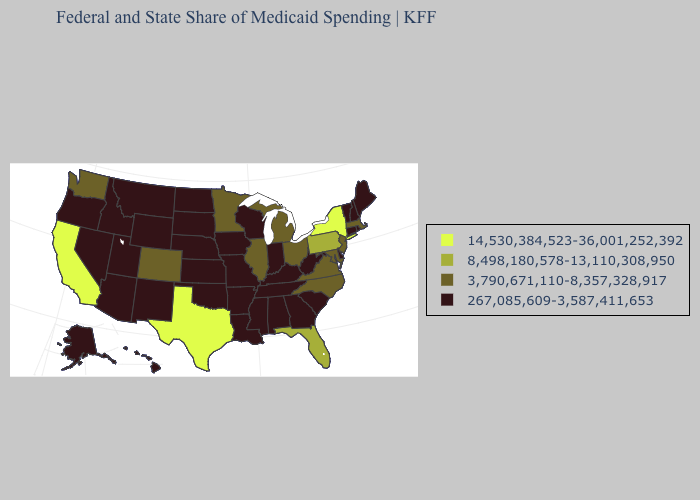Name the states that have a value in the range 267,085,609-3,587,411,653?
Concise answer only. Alabama, Alaska, Arizona, Arkansas, Connecticut, Delaware, Georgia, Hawaii, Idaho, Indiana, Iowa, Kansas, Kentucky, Louisiana, Maine, Mississippi, Missouri, Montana, Nebraska, Nevada, New Hampshire, New Mexico, North Dakota, Oklahoma, Oregon, Rhode Island, South Carolina, South Dakota, Tennessee, Utah, Vermont, West Virginia, Wisconsin, Wyoming. Which states hav the highest value in the West?
Concise answer only. California. Does Pennsylvania have the lowest value in the USA?
Give a very brief answer. No. Name the states that have a value in the range 14,530,384,523-36,001,252,392?
Concise answer only. California, New York, Texas. Name the states that have a value in the range 267,085,609-3,587,411,653?
Write a very short answer. Alabama, Alaska, Arizona, Arkansas, Connecticut, Delaware, Georgia, Hawaii, Idaho, Indiana, Iowa, Kansas, Kentucky, Louisiana, Maine, Mississippi, Missouri, Montana, Nebraska, Nevada, New Hampshire, New Mexico, North Dakota, Oklahoma, Oregon, Rhode Island, South Carolina, South Dakota, Tennessee, Utah, Vermont, West Virginia, Wisconsin, Wyoming. What is the value of Hawaii?
Short answer required. 267,085,609-3,587,411,653. What is the value of Wisconsin?
Answer briefly. 267,085,609-3,587,411,653. What is the value of Maryland?
Answer briefly. 3,790,671,110-8,357,328,917. Name the states that have a value in the range 8,498,180,578-13,110,308,950?
Quick response, please. Florida, Pennsylvania. Among the states that border New York , does Pennsylvania have the highest value?
Give a very brief answer. Yes. Does Idaho have a higher value than Virginia?
Answer briefly. No. Name the states that have a value in the range 8,498,180,578-13,110,308,950?
Concise answer only. Florida, Pennsylvania. Name the states that have a value in the range 8,498,180,578-13,110,308,950?
Quick response, please. Florida, Pennsylvania. Does Massachusetts have the lowest value in the Northeast?
Short answer required. No. 